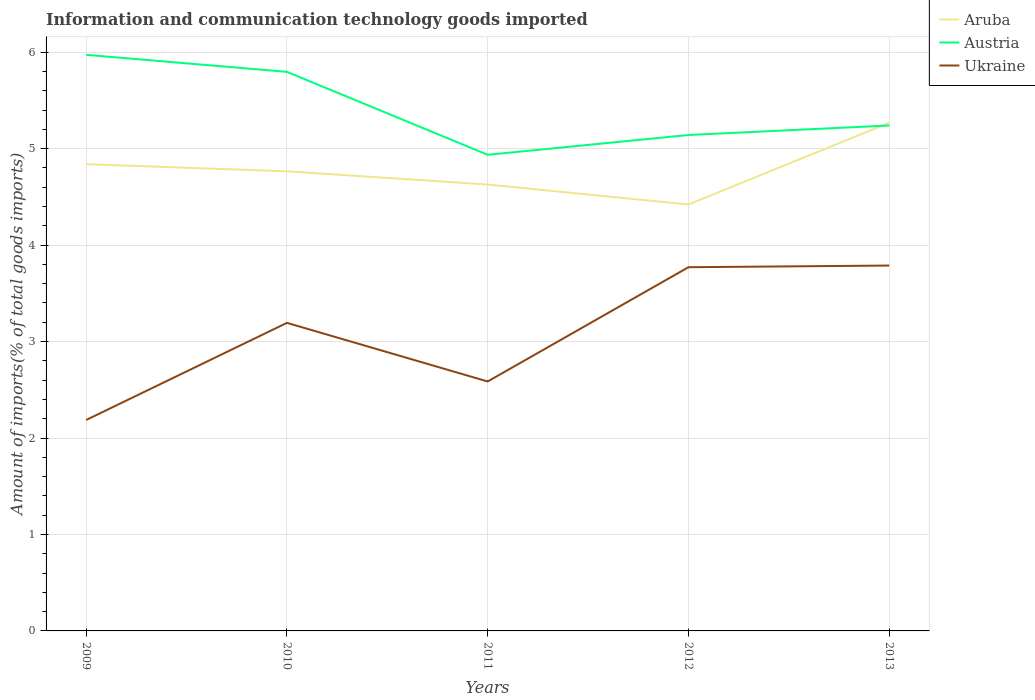Across all years, what is the maximum amount of goods imported in Ukraine?
Offer a terse response. 2.19. In which year was the amount of goods imported in Ukraine maximum?
Make the answer very short. 2009. What is the total amount of goods imported in Ukraine in the graph?
Ensure brevity in your answer.  -1.18. What is the difference between the highest and the second highest amount of goods imported in Austria?
Provide a succinct answer. 1.04. What is the difference between the highest and the lowest amount of goods imported in Austria?
Provide a succinct answer. 2. How many lines are there?
Your answer should be very brief. 3. What is the difference between two consecutive major ticks on the Y-axis?
Provide a short and direct response. 1. Are the values on the major ticks of Y-axis written in scientific E-notation?
Offer a very short reply. No. What is the title of the graph?
Your answer should be compact. Information and communication technology goods imported. Does "Romania" appear as one of the legend labels in the graph?
Provide a succinct answer. No. What is the label or title of the X-axis?
Provide a short and direct response. Years. What is the label or title of the Y-axis?
Offer a terse response. Amount of imports(% of total goods imports). What is the Amount of imports(% of total goods imports) in Aruba in 2009?
Your answer should be compact. 4.84. What is the Amount of imports(% of total goods imports) of Austria in 2009?
Offer a very short reply. 5.97. What is the Amount of imports(% of total goods imports) of Ukraine in 2009?
Make the answer very short. 2.19. What is the Amount of imports(% of total goods imports) of Aruba in 2010?
Your answer should be compact. 4.76. What is the Amount of imports(% of total goods imports) of Austria in 2010?
Provide a short and direct response. 5.8. What is the Amount of imports(% of total goods imports) of Ukraine in 2010?
Your answer should be very brief. 3.19. What is the Amount of imports(% of total goods imports) in Aruba in 2011?
Your answer should be very brief. 4.63. What is the Amount of imports(% of total goods imports) in Austria in 2011?
Your answer should be compact. 4.94. What is the Amount of imports(% of total goods imports) of Ukraine in 2011?
Keep it short and to the point. 2.59. What is the Amount of imports(% of total goods imports) of Aruba in 2012?
Provide a succinct answer. 4.42. What is the Amount of imports(% of total goods imports) in Austria in 2012?
Provide a short and direct response. 5.14. What is the Amount of imports(% of total goods imports) in Ukraine in 2012?
Provide a short and direct response. 3.77. What is the Amount of imports(% of total goods imports) of Aruba in 2013?
Your response must be concise. 5.27. What is the Amount of imports(% of total goods imports) of Austria in 2013?
Give a very brief answer. 5.24. What is the Amount of imports(% of total goods imports) of Ukraine in 2013?
Provide a short and direct response. 3.79. Across all years, what is the maximum Amount of imports(% of total goods imports) in Aruba?
Your answer should be very brief. 5.27. Across all years, what is the maximum Amount of imports(% of total goods imports) in Austria?
Your answer should be compact. 5.97. Across all years, what is the maximum Amount of imports(% of total goods imports) in Ukraine?
Provide a short and direct response. 3.79. Across all years, what is the minimum Amount of imports(% of total goods imports) in Aruba?
Provide a short and direct response. 4.42. Across all years, what is the minimum Amount of imports(% of total goods imports) of Austria?
Offer a terse response. 4.94. Across all years, what is the minimum Amount of imports(% of total goods imports) in Ukraine?
Provide a short and direct response. 2.19. What is the total Amount of imports(% of total goods imports) of Aruba in the graph?
Provide a succinct answer. 23.92. What is the total Amount of imports(% of total goods imports) of Austria in the graph?
Make the answer very short. 27.09. What is the total Amount of imports(% of total goods imports) of Ukraine in the graph?
Offer a terse response. 15.53. What is the difference between the Amount of imports(% of total goods imports) in Aruba in 2009 and that in 2010?
Keep it short and to the point. 0.07. What is the difference between the Amount of imports(% of total goods imports) in Austria in 2009 and that in 2010?
Your answer should be compact. 0.18. What is the difference between the Amount of imports(% of total goods imports) of Ukraine in 2009 and that in 2010?
Provide a short and direct response. -1.01. What is the difference between the Amount of imports(% of total goods imports) in Aruba in 2009 and that in 2011?
Offer a terse response. 0.21. What is the difference between the Amount of imports(% of total goods imports) in Austria in 2009 and that in 2011?
Make the answer very short. 1.04. What is the difference between the Amount of imports(% of total goods imports) in Ukraine in 2009 and that in 2011?
Ensure brevity in your answer.  -0.4. What is the difference between the Amount of imports(% of total goods imports) of Aruba in 2009 and that in 2012?
Keep it short and to the point. 0.42. What is the difference between the Amount of imports(% of total goods imports) of Austria in 2009 and that in 2012?
Offer a terse response. 0.83. What is the difference between the Amount of imports(% of total goods imports) in Ukraine in 2009 and that in 2012?
Your response must be concise. -1.58. What is the difference between the Amount of imports(% of total goods imports) of Aruba in 2009 and that in 2013?
Offer a very short reply. -0.43. What is the difference between the Amount of imports(% of total goods imports) in Austria in 2009 and that in 2013?
Offer a very short reply. 0.73. What is the difference between the Amount of imports(% of total goods imports) in Ukraine in 2009 and that in 2013?
Your response must be concise. -1.6. What is the difference between the Amount of imports(% of total goods imports) of Aruba in 2010 and that in 2011?
Make the answer very short. 0.14. What is the difference between the Amount of imports(% of total goods imports) of Austria in 2010 and that in 2011?
Your answer should be very brief. 0.86. What is the difference between the Amount of imports(% of total goods imports) in Ukraine in 2010 and that in 2011?
Give a very brief answer. 0.61. What is the difference between the Amount of imports(% of total goods imports) of Aruba in 2010 and that in 2012?
Provide a short and direct response. 0.34. What is the difference between the Amount of imports(% of total goods imports) in Austria in 2010 and that in 2012?
Ensure brevity in your answer.  0.65. What is the difference between the Amount of imports(% of total goods imports) of Ukraine in 2010 and that in 2012?
Ensure brevity in your answer.  -0.58. What is the difference between the Amount of imports(% of total goods imports) in Aruba in 2010 and that in 2013?
Make the answer very short. -0.5. What is the difference between the Amount of imports(% of total goods imports) in Austria in 2010 and that in 2013?
Provide a short and direct response. 0.56. What is the difference between the Amount of imports(% of total goods imports) in Ukraine in 2010 and that in 2013?
Your answer should be compact. -0.59. What is the difference between the Amount of imports(% of total goods imports) of Aruba in 2011 and that in 2012?
Make the answer very short. 0.21. What is the difference between the Amount of imports(% of total goods imports) of Austria in 2011 and that in 2012?
Provide a short and direct response. -0.21. What is the difference between the Amount of imports(% of total goods imports) in Ukraine in 2011 and that in 2012?
Your answer should be compact. -1.18. What is the difference between the Amount of imports(% of total goods imports) of Aruba in 2011 and that in 2013?
Keep it short and to the point. -0.64. What is the difference between the Amount of imports(% of total goods imports) in Austria in 2011 and that in 2013?
Keep it short and to the point. -0.3. What is the difference between the Amount of imports(% of total goods imports) in Ukraine in 2011 and that in 2013?
Ensure brevity in your answer.  -1.2. What is the difference between the Amount of imports(% of total goods imports) of Aruba in 2012 and that in 2013?
Your answer should be compact. -0.85. What is the difference between the Amount of imports(% of total goods imports) of Austria in 2012 and that in 2013?
Your answer should be compact. -0.1. What is the difference between the Amount of imports(% of total goods imports) of Ukraine in 2012 and that in 2013?
Offer a terse response. -0.02. What is the difference between the Amount of imports(% of total goods imports) in Aruba in 2009 and the Amount of imports(% of total goods imports) in Austria in 2010?
Offer a very short reply. -0.96. What is the difference between the Amount of imports(% of total goods imports) of Aruba in 2009 and the Amount of imports(% of total goods imports) of Ukraine in 2010?
Offer a terse response. 1.65. What is the difference between the Amount of imports(% of total goods imports) of Austria in 2009 and the Amount of imports(% of total goods imports) of Ukraine in 2010?
Ensure brevity in your answer.  2.78. What is the difference between the Amount of imports(% of total goods imports) in Aruba in 2009 and the Amount of imports(% of total goods imports) in Austria in 2011?
Offer a terse response. -0.1. What is the difference between the Amount of imports(% of total goods imports) in Aruba in 2009 and the Amount of imports(% of total goods imports) in Ukraine in 2011?
Your answer should be compact. 2.25. What is the difference between the Amount of imports(% of total goods imports) of Austria in 2009 and the Amount of imports(% of total goods imports) of Ukraine in 2011?
Provide a short and direct response. 3.39. What is the difference between the Amount of imports(% of total goods imports) in Aruba in 2009 and the Amount of imports(% of total goods imports) in Austria in 2012?
Make the answer very short. -0.3. What is the difference between the Amount of imports(% of total goods imports) in Aruba in 2009 and the Amount of imports(% of total goods imports) in Ukraine in 2012?
Ensure brevity in your answer.  1.07. What is the difference between the Amount of imports(% of total goods imports) of Austria in 2009 and the Amount of imports(% of total goods imports) of Ukraine in 2012?
Your answer should be compact. 2.2. What is the difference between the Amount of imports(% of total goods imports) of Aruba in 2009 and the Amount of imports(% of total goods imports) of Austria in 2013?
Offer a very short reply. -0.4. What is the difference between the Amount of imports(% of total goods imports) in Aruba in 2009 and the Amount of imports(% of total goods imports) in Ukraine in 2013?
Keep it short and to the point. 1.05. What is the difference between the Amount of imports(% of total goods imports) in Austria in 2009 and the Amount of imports(% of total goods imports) in Ukraine in 2013?
Offer a very short reply. 2.18. What is the difference between the Amount of imports(% of total goods imports) in Aruba in 2010 and the Amount of imports(% of total goods imports) in Austria in 2011?
Keep it short and to the point. -0.17. What is the difference between the Amount of imports(% of total goods imports) in Aruba in 2010 and the Amount of imports(% of total goods imports) in Ukraine in 2011?
Offer a terse response. 2.18. What is the difference between the Amount of imports(% of total goods imports) of Austria in 2010 and the Amount of imports(% of total goods imports) of Ukraine in 2011?
Provide a succinct answer. 3.21. What is the difference between the Amount of imports(% of total goods imports) of Aruba in 2010 and the Amount of imports(% of total goods imports) of Austria in 2012?
Provide a short and direct response. -0.38. What is the difference between the Amount of imports(% of total goods imports) in Aruba in 2010 and the Amount of imports(% of total goods imports) in Ukraine in 2012?
Make the answer very short. 0.99. What is the difference between the Amount of imports(% of total goods imports) of Austria in 2010 and the Amount of imports(% of total goods imports) of Ukraine in 2012?
Offer a very short reply. 2.03. What is the difference between the Amount of imports(% of total goods imports) in Aruba in 2010 and the Amount of imports(% of total goods imports) in Austria in 2013?
Provide a short and direct response. -0.47. What is the difference between the Amount of imports(% of total goods imports) in Austria in 2010 and the Amount of imports(% of total goods imports) in Ukraine in 2013?
Keep it short and to the point. 2.01. What is the difference between the Amount of imports(% of total goods imports) in Aruba in 2011 and the Amount of imports(% of total goods imports) in Austria in 2012?
Your response must be concise. -0.51. What is the difference between the Amount of imports(% of total goods imports) of Aruba in 2011 and the Amount of imports(% of total goods imports) of Ukraine in 2012?
Give a very brief answer. 0.86. What is the difference between the Amount of imports(% of total goods imports) in Austria in 2011 and the Amount of imports(% of total goods imports) in Ukraine in 2012?
Provide a short and direct response. 1.17. What is the difference between the Amount of imports(% of total goods imports) in Aruba in 2011 and the Amount of imports(% of total goods imports) in Austria in 2013?
Give a very brief answer. -0.61. What is the difference between the Amount of imports(% of total goods imports) of Aruba in 2011 and the Amount of imports(% of total goods imports) of Ukraine in 2013?
Your answer should be compact. 0.84. What is the difference between the Amount of imports(% of total goods imports) of Austria in 2011 and the Amount of imports(% of total goods imports) of Ukraine in 2013?
Your answer should be compact. 1.15. What is the difference between the Amount of imports(% of total goods imports) in Aruba in 2012 and the Amount of imports(% of total goods imports) in Austria in 2013?
Keep it short and to the point. -0.82. What is the difference between the Amount of imports(% of total goods imports) of Aruba in 2012 and the Amount of imports(% of total goods imports) of Ukraine in 2013?
Keep it short and to the point. 0.63. What is the difference between the Amount of imports(% of total goods imports) of Austria in 2012 and the Amount of imports(% of total goods imports) of Ukraine in 2013?
Your answer should be compact. 1.35. What is the average Amount of imports(% of total goods imports) in Aruba per year?
Your answer should be very brief. 4.78. What is the average Amount of imports(% of total goods imports) in Austria per year?
Your answer should be very brief. 5.42. What is the average Amount of imports(% of total goods imports) of Ukraine per year?
Your response must be concise. 3.1. In the year 2009, what is the difference between the Amount of imports(% of total goods imports) of Aruba and Amount of imports(% of total goods imports) of Austria?
Offer a terse response. -1.13. In the year 2009, what is the difference between the Amount of imports(% of total goods imports) of Aruba and Amount of imports(% of total goods imports) of Ukraine?
Keep it short and to the point. 2.65. In the year 2009, what is the difference between the Amount of imports(% of total goods imports) in Austria and Amount of imports(% of total goods imports) in Ukraine?
Offer a very short reply. 3.79. In the year 2010, what is the difference between the Amount of imports(% of total goods imports) in Aruba and Amount of imports(% of total goods imports) in Austria?
Provide a succinct answer. -1.03. In the year 2010, what is the difference between the Amount of imports(% of total goods imports) of Aruba and Amount of imports(% of total goods imports) of Ukraine?
Make the answer very short. 1.57. In the year 2010, what is the difference between the Amount of imports(% of total goods imports) in Austria and Amount of imports(% of total goods imports) in Ukraine?
Keep it short and to the point. 2.6. In the year 2011, what is the difference between the Amount of imports(% of total goods imports) of Aruba and Amount of imports(% of total goods imports) of Austria?
Make the answer very short. -0.31. In the year 2011, what is the difference between the Amount of imports(% of total goods imports) of Aruba and Amount of imports(% of total goods imports) of Ukraine?
Your answer should be compact. 2.04. In the year 2011, what is the difference between the Amount of imports(% of total goods imports) of Austria and Amount of imports(% of total goods imports) of Ukraine?
Your response must be concise. 2.35. In the year 2012, what is the difference between the Amount of imports(% of total goods imports) in Aruba and Amount of imports(% of total goods imports) in Austria?
Ensure brevity in your answer.  -0.72. In the year 2012, what is the difference between the Amount of imports(% of total goods imports) of Aruba and Amount of imports(% of total goods imports) of Ukraine?
Your response must be concise. 0.65. In the year 2012, what is the difference between the Amount of imports(% of total goods imports) in Austria and Amount of imports(% of total goods imports) in Ukraine?
Provide a short and direct response. 1.37. In the year 2013, what is the difference between the Amount of imports(% of total goods imports) in Aruba and Amount of imports(% of total goods imports) in Austria?
Make the answer very short. 0.03. In the year 2013, what is the difference between the Amount of imports(% of total goods imports) in Aruba and Amount of imports(% of total goods imports) in Ukraine?
Your answer should be very brief. 1.48. In the year 2013, what is the difference between the Amount of imports(% of total goods imports) in Austria and Amount of imports(% of total goods imports) in Ukraine?
Offer a very short reply. 1.45. What is the ratio of the Amount of imports(% of total goods imports) of Aruba in 2009 to that in 2010?
Ensure brevity in your answer.  1.02. What is the ratio of the Amount of imports(% of total goods imports) in Austria in 2009 to that in 2010?
Your answer should be compact. 1.03. What is the ratio of the Amount of imports(% of total goods imports) in Ukraine in 2009 to that in 2010?
Offer a very short reply. 0.68. What is the ratio of the Amount of imports(% of total goods imports) in Aruba in 2009 to that in 2011?
Provide a succinct answer. 1.05. What is the ratio of the Amount of imports(% of total goods imports) of Austria in 2009 to that in 2011?
Your answer should be very brief. 1.21. What is the ratio of the Amount of imports(% of total goods imports) in Ukraine in 2009 to that in 2011?
Your response must be concise. 0.85. What is the ratio of the Amount of imports(% of total goods imports) of Aruba in 2009 to that in 2012?
Give a very brief answer. 1.09. What is the ratio of the Amount of imports(% of total goods imports) of Austria in 2009 to that in 2012?
Keep it short and to the point. 1.16. What is the ratio of the Amount of imports(% of total goods imports) of Ukraine in 2009 to that in 2012?
Give a very brief answer. 0.58. What is the ratio of the Amount of imports(% of total goods imports) in Aruba in 2009 to that in 2013?
Ensure brevity in your answer.  0.92. What is the ratio of the Amount of imports(% of total goods imports) in Austria in 2009 to that in 2013?
Provide a short and direct response. 1.14. What is the ratio of the Amount of imports(% of total goods imports) in Ukraine in 2009 to that in 2013?
Give a very brief answer. 0.58. What is the ratio of the Amount of imports(% of total goods imports) of Aruba in 2010 to that in 2011?
Your answer should be compact. 1.03. What is the ratio of the Amount of imports(% of total goods imports) of Austria in 2010 to that in 2011?
Offer a terse response. 1.17. What is the ratio of the Amount of imports(% of total goods imports) of Ukraine in 2010 to that in 2011?
Offer a very short reply. 1.24. What is the ratio of the Amount of imports(% of total goods imports) in Aruba in 2010 to that in 2012?
Your answer should be very brief. 1.08. What is the ratio of the Amount of imports(% of total goods imports) in Austria in 2010 to that in 2012?
Offer a terse response. 1.13. What is the ratio of the Amount of imports(% of total goods imports) in Ukraine in 2010 to that in 2012?
Your answer should be compact. 0.85. What is the ratio of the Amount of imports(% of total goods imports) in Aruba in 2010 to that in 2013?
Your answer should be compact. 0.9. What is the ratio of the Amount of imports(% of total goods imports) of Austria in 2010 to that in 2013?
Give a very brief answer. 1.11. What is the ratio of the Amount of imports(% of total goods imports) of Ukraine in 2010 to that in 2013?
Keep it short and to the point. 0.84. What is the ratio of the Amount of imports(% of total goods imports) in Aruba in 2011 to that in 2012?
Your response must be concise. 1.05. What is the ratio of the Amount of imports(% of total goods imports) in Austria in 2011 to that in 2012?
Ensure brevity in your answer.  0.96. What is the ratio of the Amount of imports(% of total goods imports) in Ukraine in 2011 to that in 2012?
Your answer should be compact. 0.69. What is the ratio of the Amount of imports(% of total goods imports) in Aruba in 2011 to that in 2013?
Provide a succinct answer. 0.88. What is the ratio of the Amount of imports(% of total goods imports) in Austria in 2011 to that in 2013?
Provide a succinct answer. 0.94. What is the ratio of the Amount of imports(% of total goods imports) in Ukraine in 2011 to that in 2013?
Make the answer very short. 0.68. What is the ratio of the Amount of imports(% of total goods imports) in Aruba in 2012 to that in 2013?
Give a very brief answer. 0.84. What is the ratio of the Amount of imports(% of total goods imports) of Austria in 2012 to that in 2013?
Give a very brief answer. 0.98. What is the difference between the highest and the second highest Amount of imports(% of total goods imports) in Aruba?
Give a very brief answer. 0.43. What is the difference between the highest and the second highest Amount of imports(% of total goods imports) in Austria?
Offer a terse response. 0.18. What is the difference between the highest and the second highest Amount of imports(% of total goods imports) of Ukraine?
Ensure brevity in your answer.  0.02. What is the difference between the highest and the lowest Amount of imports(% of total goods imports) of Aruba?
Offer a terse response. 0.85. What is the difference between the highest and the lowest Amount of imports(% of total goods imports) in Austria?
Your answer should be compact. 1.04. What is the difference between the highest and the lowest Amount of imports(% of total goods imports) of Ukraine?
Give a very brief answer. 1.6. 